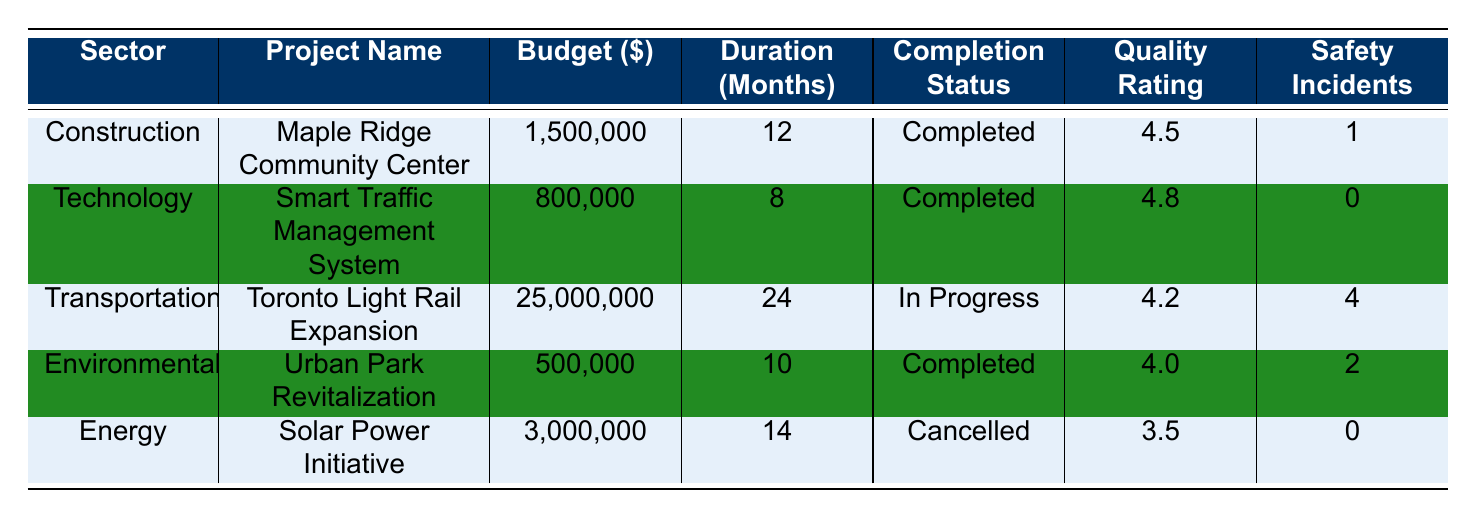What is the budget of the "Smart Traffic Management System"? The budget for the project named "Smart Traffic Management System" is specified in the table and is listed under the Budget column for that project.
Answer: 800000 What is the Quality Rating of the "Solar Power Initiative"? To find the Quality Rating for the "Solar Power Initiative", we refer to the corresponding row in the table under the Quality Rating column.
Answer: 3.5 How many total safety incidents were recorded across all completed projects? From the table, the completed projects are: "Maple Ridge Community Center," "Smart Traffic Management System," and "Urban Park Revitalization." We sum their safety incidents: 1 + 0 + 2 = 3.
Answer: 3 Is the "Toronto Light Rail Expansion" completed? By checking the Completion Status column in the table for the "Toronto Light Rail Expansion," we see that its status is "In Progress," not completed.
Answer: No What is the average budget of projects in the "Construction" and "Environmental" sectors combined? We first find the budgets for the relevant sectors: "Construction" has a budget of 1500000, and "Environmental" has a budget of 500000. The total budget is 1500000 + 500000 = 2000000. Since there are 2 projects, the average is 2000000 / 2 = 1000000.
Answer: 1000000 Which sector has the highest Quality Rating among the completed projects? We look at the Quality Ratings for all completed projects: Maple Ridge Community Center (4.5), Smart Traffic Management System (4.8), Urban Park Revitalization (4.0). The highest rating is for the Smart Traffic Management System which has a rating of 4.8.
Answer: Technology How many projects have a duration of 12 months or longer? From the table, we review each project's duration: "Maple Ridge Community Center" (12), "Toronto Light Rail Expansion" (24), and "Solar Power Initiative" (14) qualify, totaling 3 projects.
Answer: 3 Does any project in the "Energy" sector have a Quality Rating of 4 or higher? The only project listed in the Energy sector is the "Solar Power Initiative," which has a Quality Rating of 3.5. Since 3.5 is less than 4, the answer is no.
Answer: No 